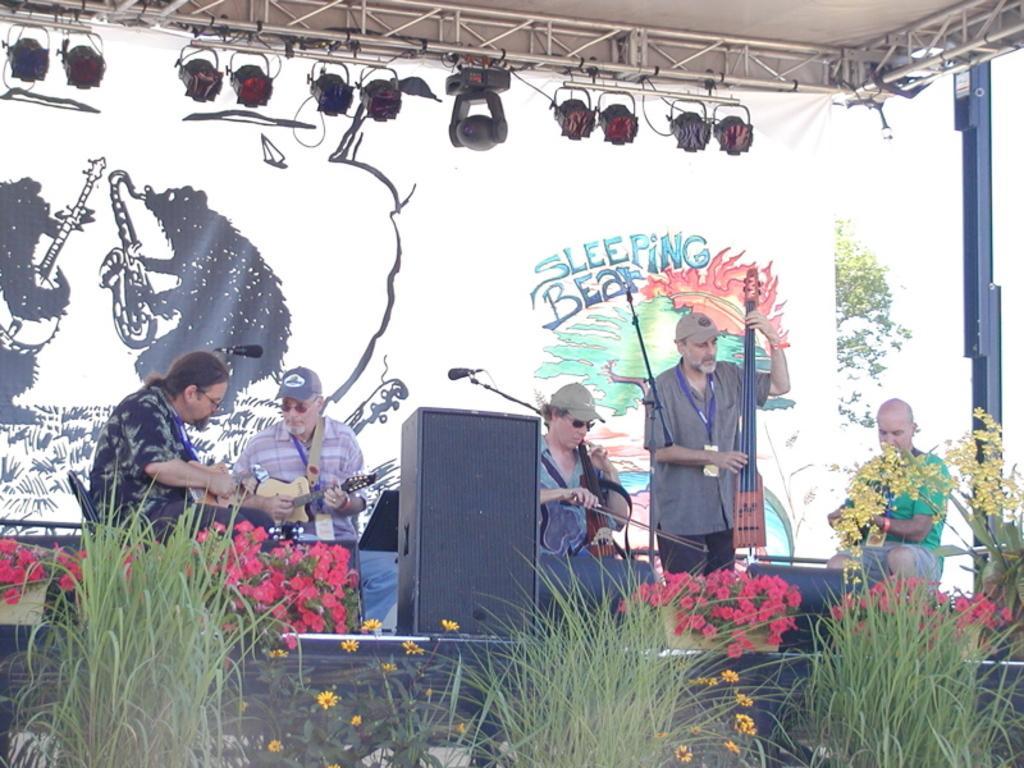Describe this image in one or two sentences. In this picture we can see some persons are sitting on the chairs. They are playing guitar. Here we can see a man who is standing on the floor. This is mike and these are the plants and there are some flowers. On the background there is a banner. And there is a tree. These are the lights. 